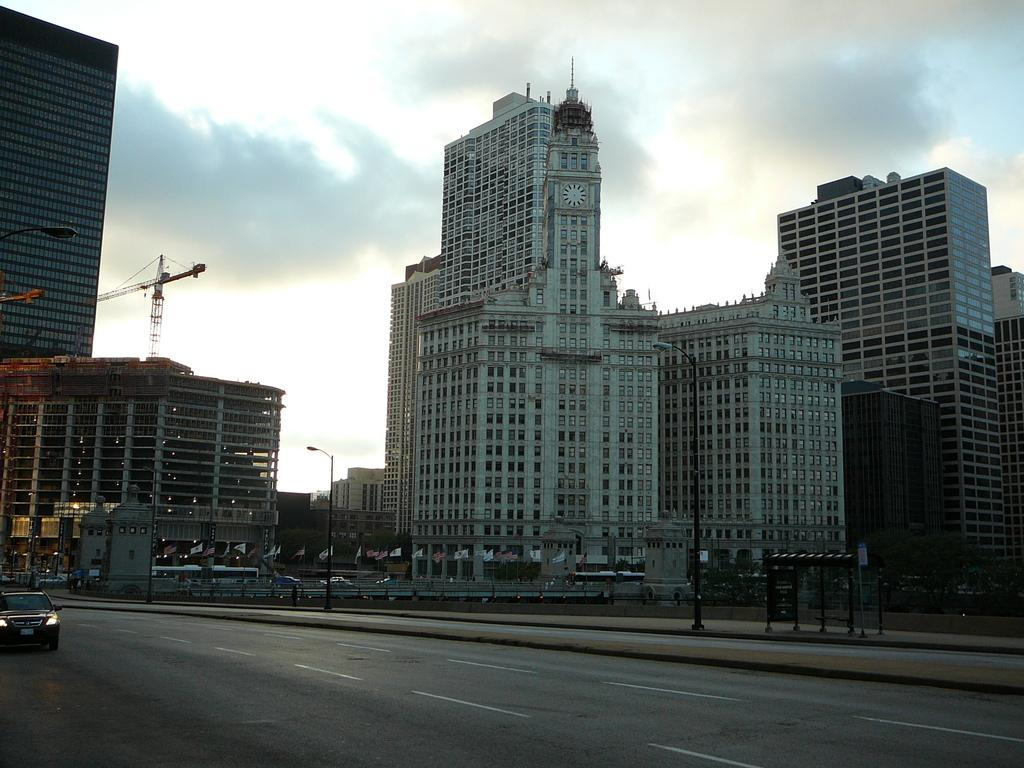What type of structures can be seen in the image? There are buildings in the image. What other objects are present in the image? There are poles, a crane, vehicles on the road, and flags in the image. What can be seen in the background of the image? The sky is visible in the background of the image. Where are the cherries being stored in the image? There are no cherries present in the image. What type of thrill can be experienced by the doll in the image? There is no doll present in the image, so it is not possible to determine what type of thrill the doll might experience. 